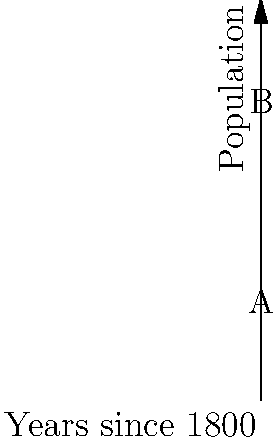As a curious traveler exploring Westport's historical landmarks, you come across a graph representing the town's population growth since 1800. The curve is modeled by the function $f(x) = 5000 + 500x + 50x^2$, where $x$ represents the number of decades since 1800, and $f(x)$ represents the population. Calculate the total population growth from 1800 to 1900 using the definite integral of this function. To find the total population growth from 1800 to 1900, we need to calculate the area under the curve from $x=0$ (1800) to $x=10$ (1900). This can be done using a definite integral.

Step 1: Set up the definite integral
$$\int_0^{10} (5000 + 500x + 50x^2) dx$$

Step 2: Integrate the function
$$\left[5000x + 250x^2 + \frac{50}{3}x^3\right]_0^{10}$$

Step 3: Evaluate the integral at the upper and lower bounds
Upper bound: $5000(10) + 250(10^2) + \frac{50}{3}(10^3) = 50000 + 25000 + \frac{50000}{3}$
Lower bound: $5000(0) + 250(0^2) + \frac{50}{3}(0^3) = 0$

Step 4: Subtract the lower bound from the upper bound
$$(50000 + 25000 + \frac{50000}{3}) - 0 = 75000 + \frac{50000}{3}$$

Step 5: Simplify the result
$$75000 + \frac{50000}{3} = \frac{225000 + 50000}{3} = \frac{275000}{3}$$

Therefore, the total population growth from 1800 to 1900 is $\frac{275000}{3}$ people.
Answer: $\frac{275000}{3}$ people 